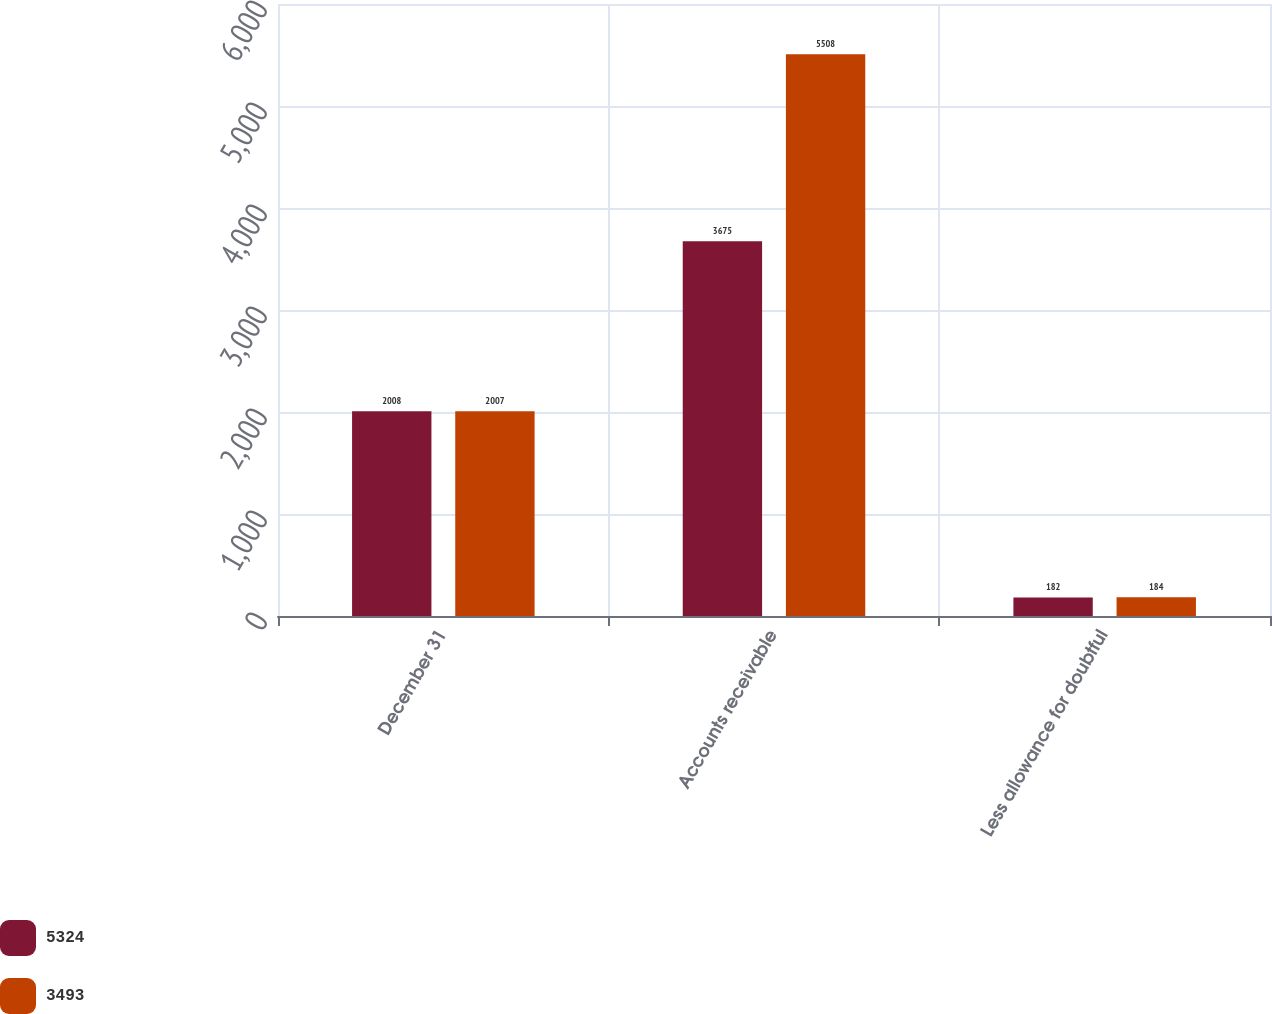Convert chart to OTSL. <chart><loc_0><loc_0><loc_500><loc_500><stacked_bar_chart><ecel><fcel>December 31<fcel>Accounts receivable<fcel>Less allowance for doubtful<nl><fcel>5324<fcel>2008<fcel>3675<fcel>182<nl><fcel>3493<fcel>2007<fcel>5508<fcel>184<nl></chart> 